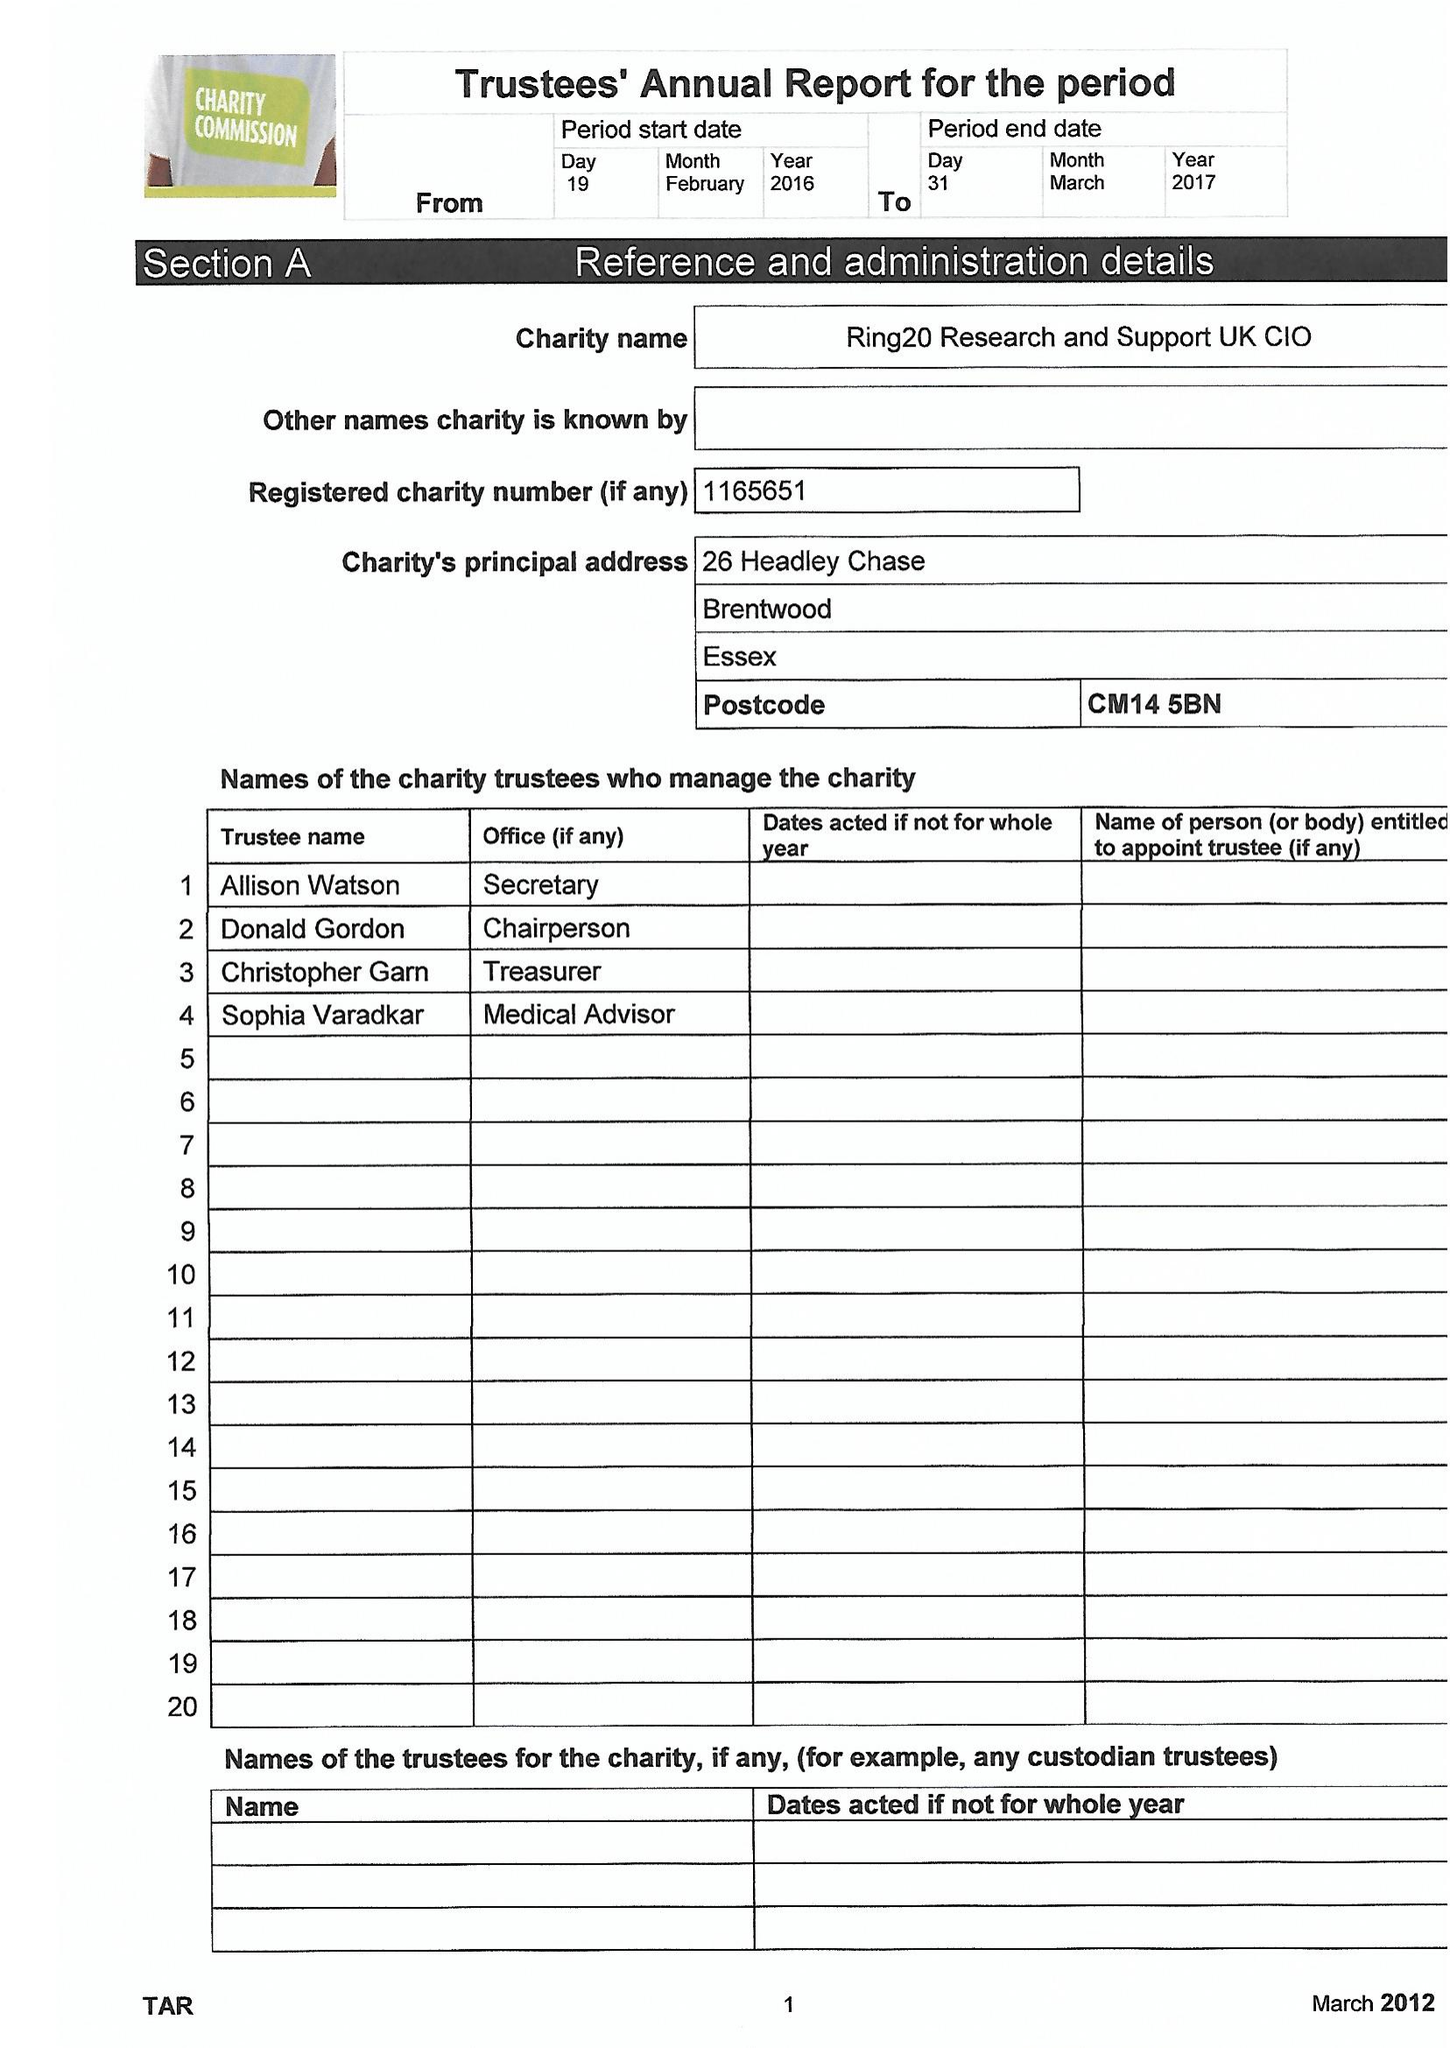What is the value for the income_annually_in_british_pounds?
Answer the question using a single word or phrase. 19508.00 